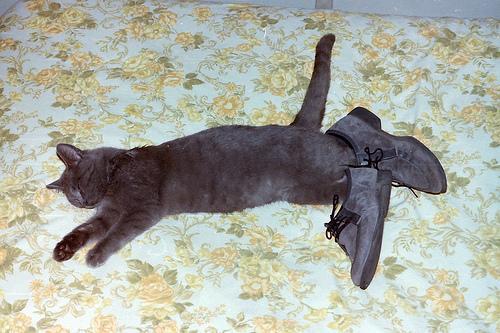How many cats are shown?
Give a very brief answer. 1. 